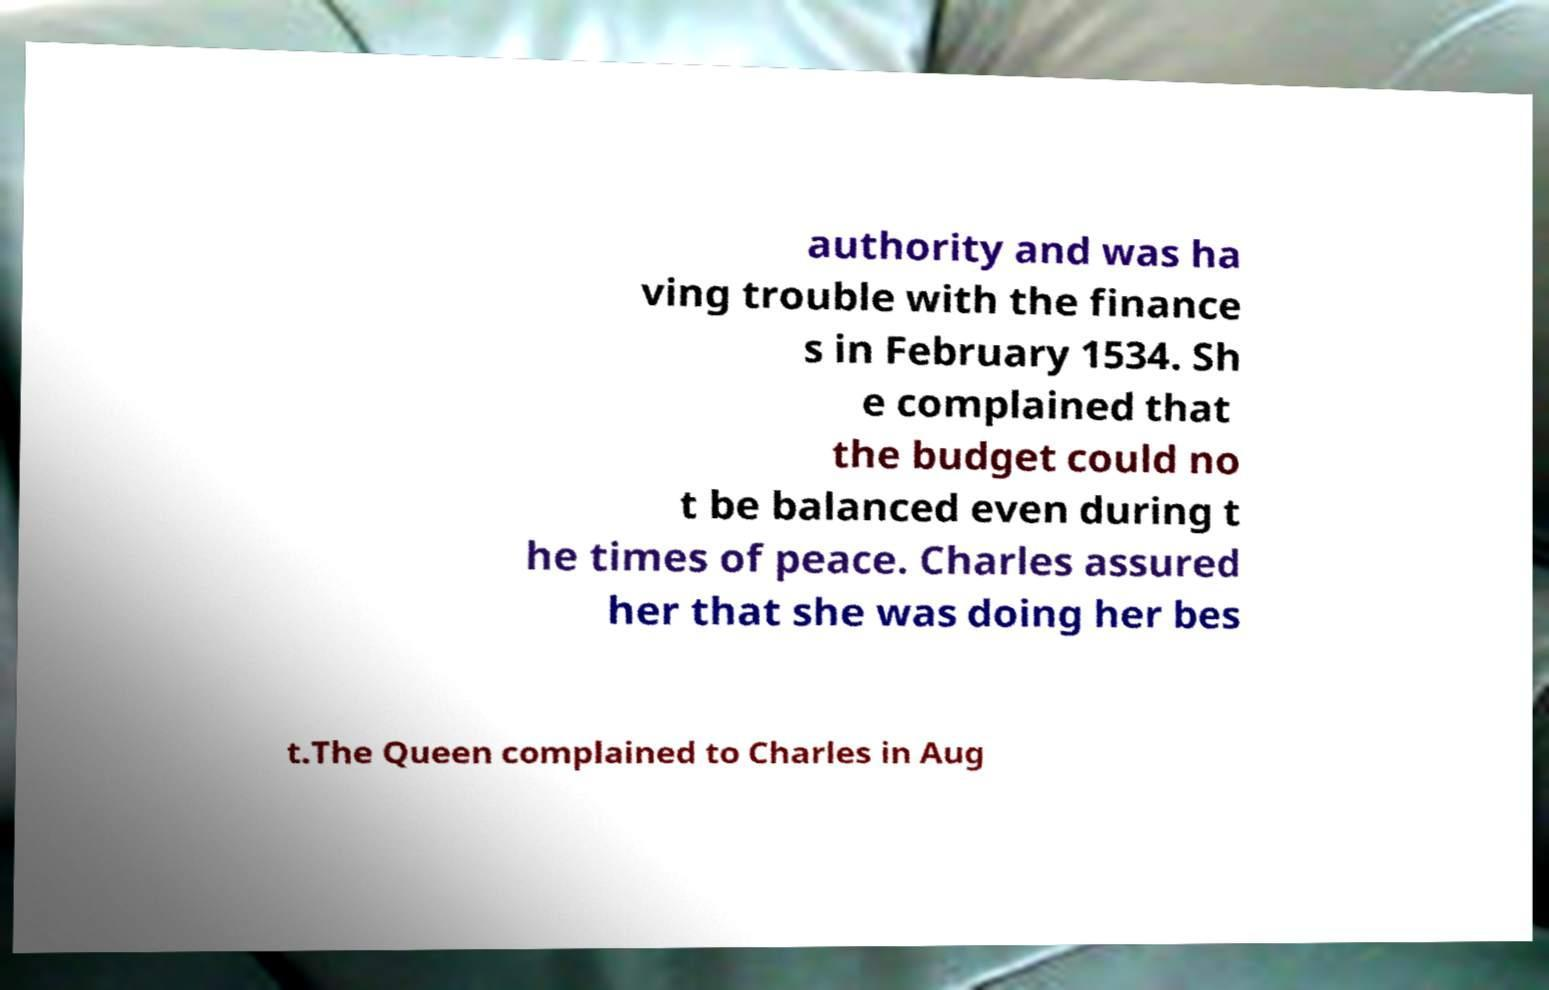For documentation purposes, I need the text within this image transcribed. Could you provide that? authority and was ha ving trouble with the finance s in February 1534. Sh e complained that the budget could no t be balanced even during t he times of peace. Charles assured her that she was doing her bes t.The Queen complained to Charles in Aug 